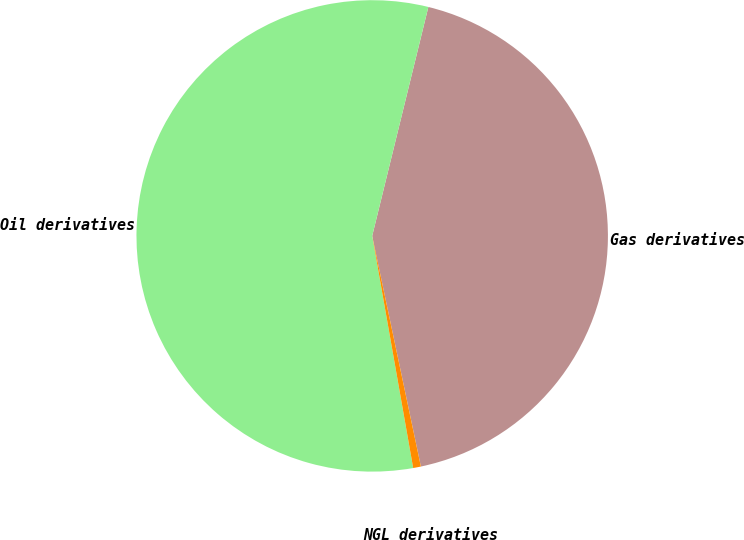<chart> <loc_0><loc_0><loc_500><loc_500><pie_chart><fcel>Gas derivatives<fcel>Oil derivatives<fcel>NGL derivatives<nl><fcel>42.86%<fcel>56.61%<fcel>0.53%<nl></chart> 